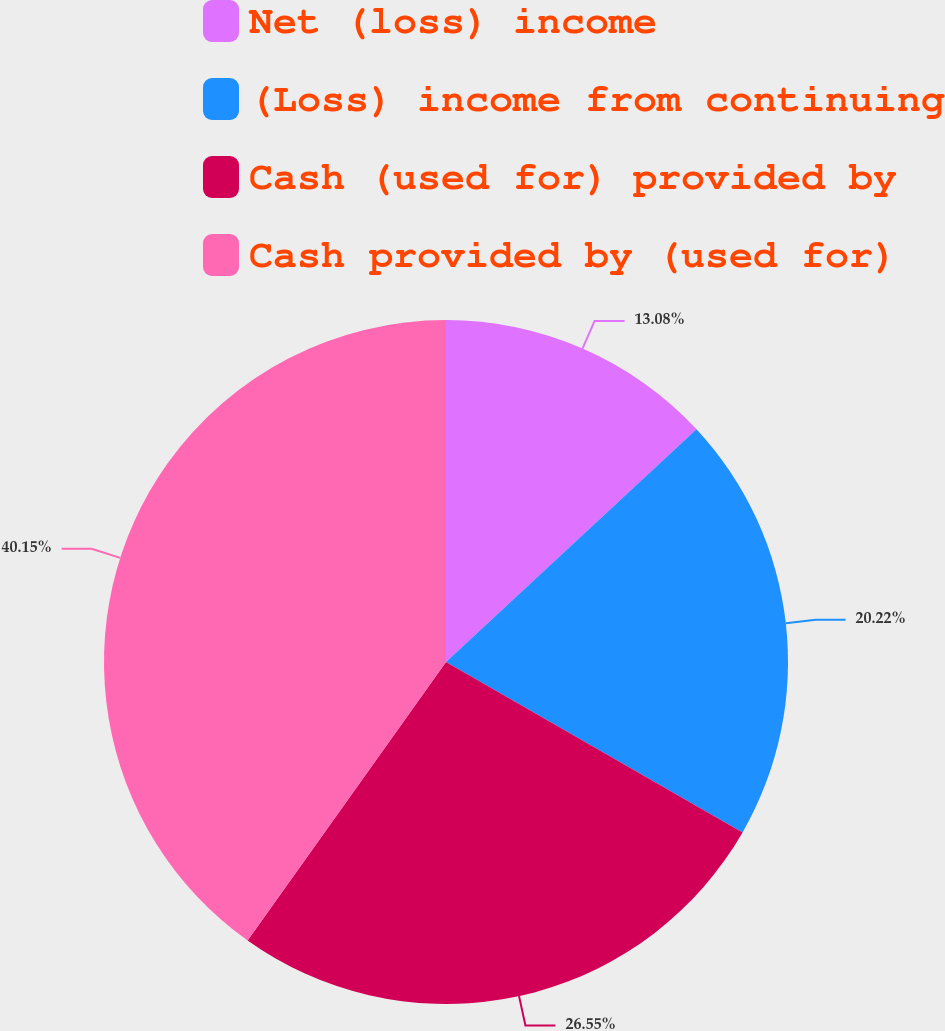Convert chart to OTSL. <chart><loc_0><loc_0><loc_500><loc_500><pie_chart><fcel>Net (loss) income<fcel>(Loss) income from continuing<fcel>Cash (used for) provided by<fcel>Cash provided by (used for)<nl><fcel>13.08%<fcel>20.22%<fcel>26.55%<fcel>40.15%<nl></chart> 